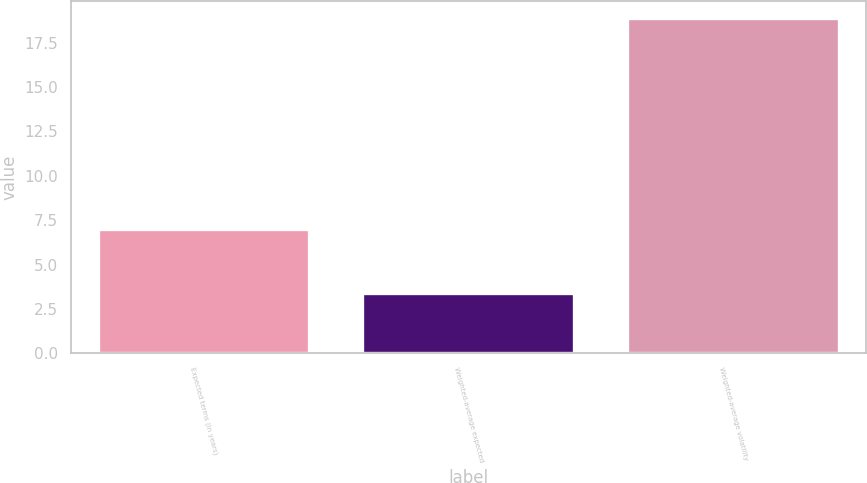Convert chart to OTSL. <chart><loc_0><loc_0><loc_500><loc_500><bar_chart><fcel>Expected terms (in years)<fcel>Weighted-average expected<fcel>Weighted-average volatility<nl><fcel>7<fcel>3.4<fcel>18.9<nl></chart> 